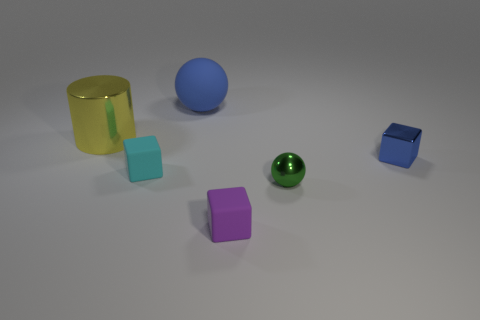Does the cylinder have the same material as the tiny green thing?
Your response must be concise. Yes. What is the shape of the small object that is on the left side of the small purple object?
Provide a succinct answer. Cube. Are there any tiny things on the left side of the sphere that is in front of the large yellow shiny cylinder?
Offer a very short reply. Yes. Are there any blue spheres of the same size as the yellow shiny cylinder?
Your answer should be very brief. Yes. There is a sphere behind the small cyan cube; is its color the same as the shiny cube?
Offer a very short reply. Yes. How big is the matte ball?
Your answer should be very brief. Large. There is a sphere behind the tiny rubber object that is on the left side of the big matte sphere; what is its size?
Ensure brevity in your answer.  Large. How many big things are the same color as the large shiny cylinder?
Make the answer very short. 0. How many blue metal cubes are there?
Give a very brief answer. 1. How many big blue spheres are the same material as the cyan thing?
Provide a succinct answer. 1. 